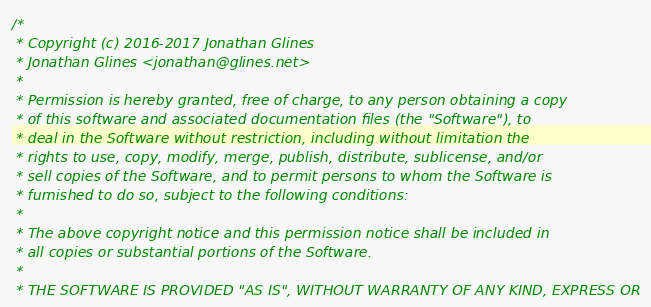<code> <loc_0><loc_0><loc_500><loc_500><_C_>/*
 * Copyright (c) 2016-2017 Jonathan Glines
 * Jonathan Glines <jonathan@glines.net>
 *
 * Permission is hereby granted, free of charge, to any person obtaining a copy
 * of this software and associated documentation files (the "Software"), to
 * deal in the Software without restriction, including without limitation the
 * rights to use, copy, modify, merge, publish, distribute, sublicense, and/or
 * sell copies of the Software, and to permit persons to whom the Software is
 * furnished to do so, subject to the following conditions:
 *
 * The above copyright notice and this permission notice shall be included in
 * all copies or substantial portions of the Software.
 *
 * THE SOFTWARE IS PROVIDED "AS IS", WITHOUT WARRANTY OF ANY KIND, EXPRESS OR</code> 